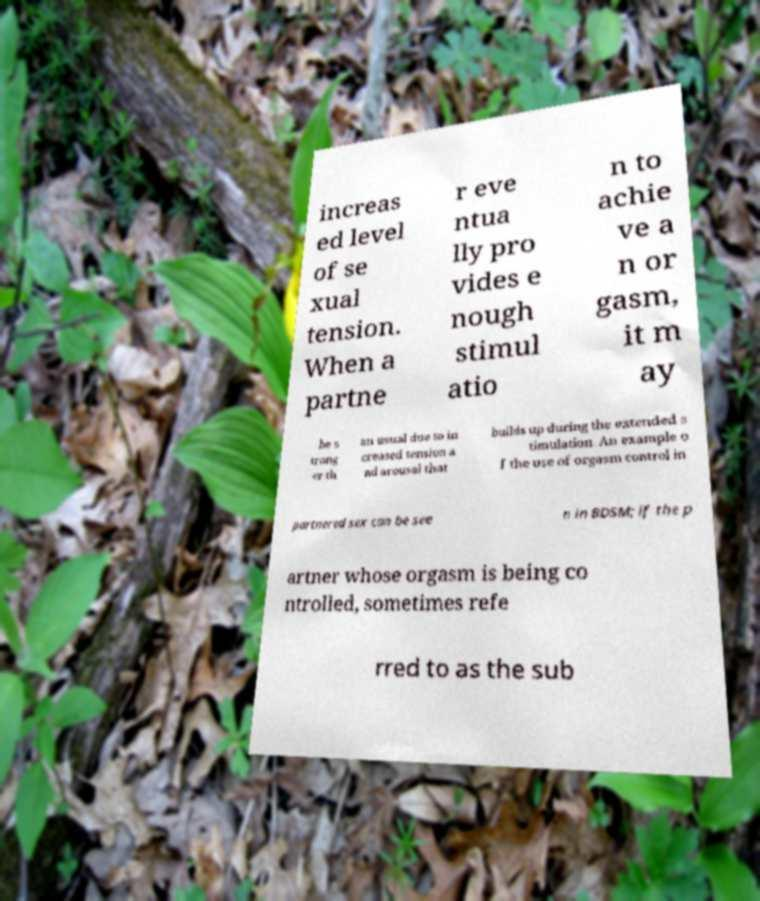Please identify and transcribe the text found in this image. increas ed level of se xual tension. When a partne r eve ntua lly pro vides e nough stimul atio n to achie ve a n or gasm, it m ay be s trong er th an usual due to in creased tension a nd arousal that builds up during the extended s timulation. An example o f the use of orgasm control in partnered sex can be see n in BDSM; if the p artner whose orgasm is being co ntrolled, sometimes refe rred to as the sub 